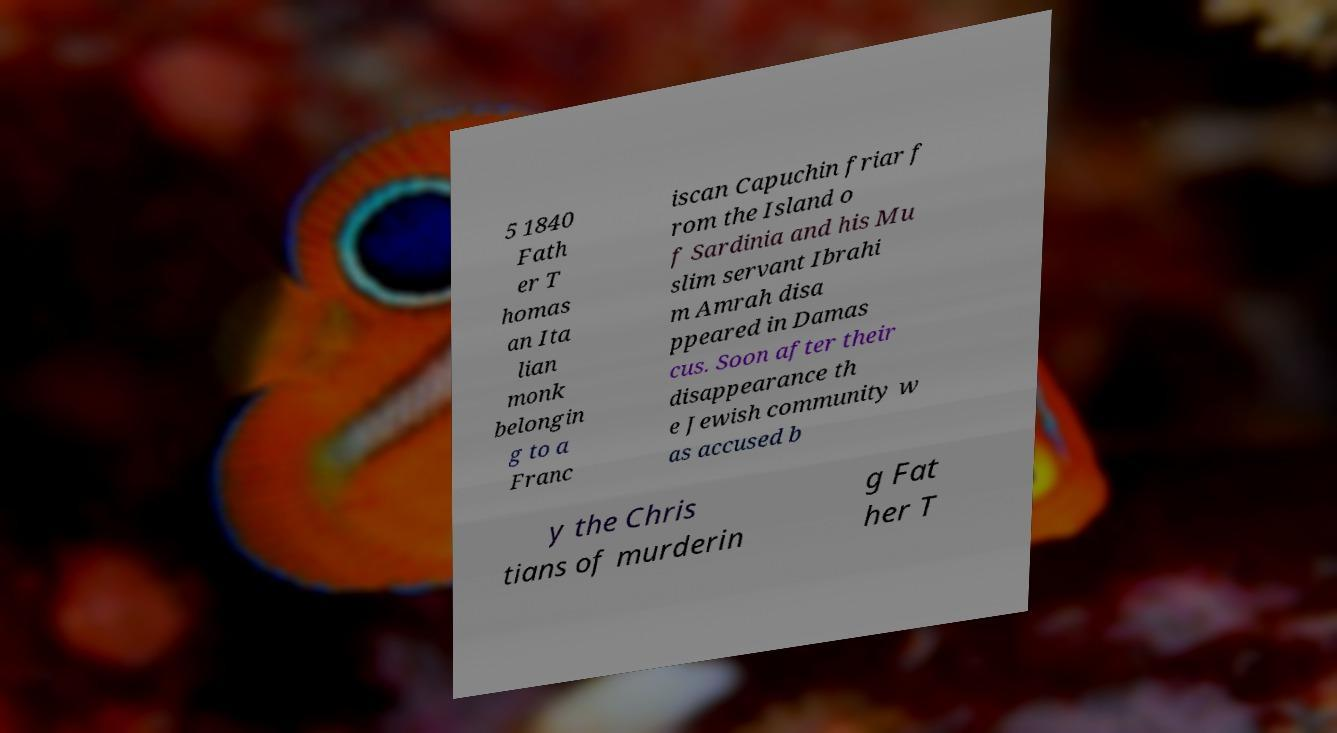Can you read and provide the text displayed in the image?This photo seems to have some interesting text. Can you extract and type it out for me? 5 1840 Fath er T homas an Ita lian monk belongin g to a Franc iscan Capuchin friar f rom the Island o f Sardinia and his Mu slim servant Ibrahi m Amrah disa ppeared in Damas cus. Soon after their disappearance th e Jewish community w as accused b y the Chris tians of murderin g Fat her T 